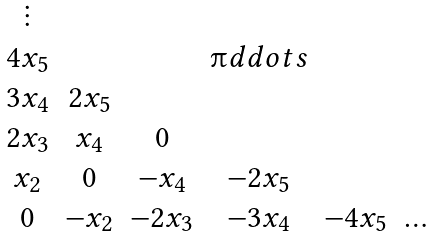Convert formula to latex. <formula><loc_0><loc_0><loc_500><loc_500>\begin{matrix} \vdots & & & & \\ 4 x _ { 5 } & & & \i d d o t s & \\ 3 x _ { 4 } & 2 x _ { 5 } & & & \\ 2 x _ { 3 } & x _ { 4 } & 0 & & \\ x _ { 2 } & 0 & - x _ { 4 } & - 2 x _ { 5 } & \\ 0 & - x _ { 2 } & - 2 x _ { 3 } & - 3 x _ { 4 } & - 4 x _ { 5 } & \dots \end{matrix}</formula> 